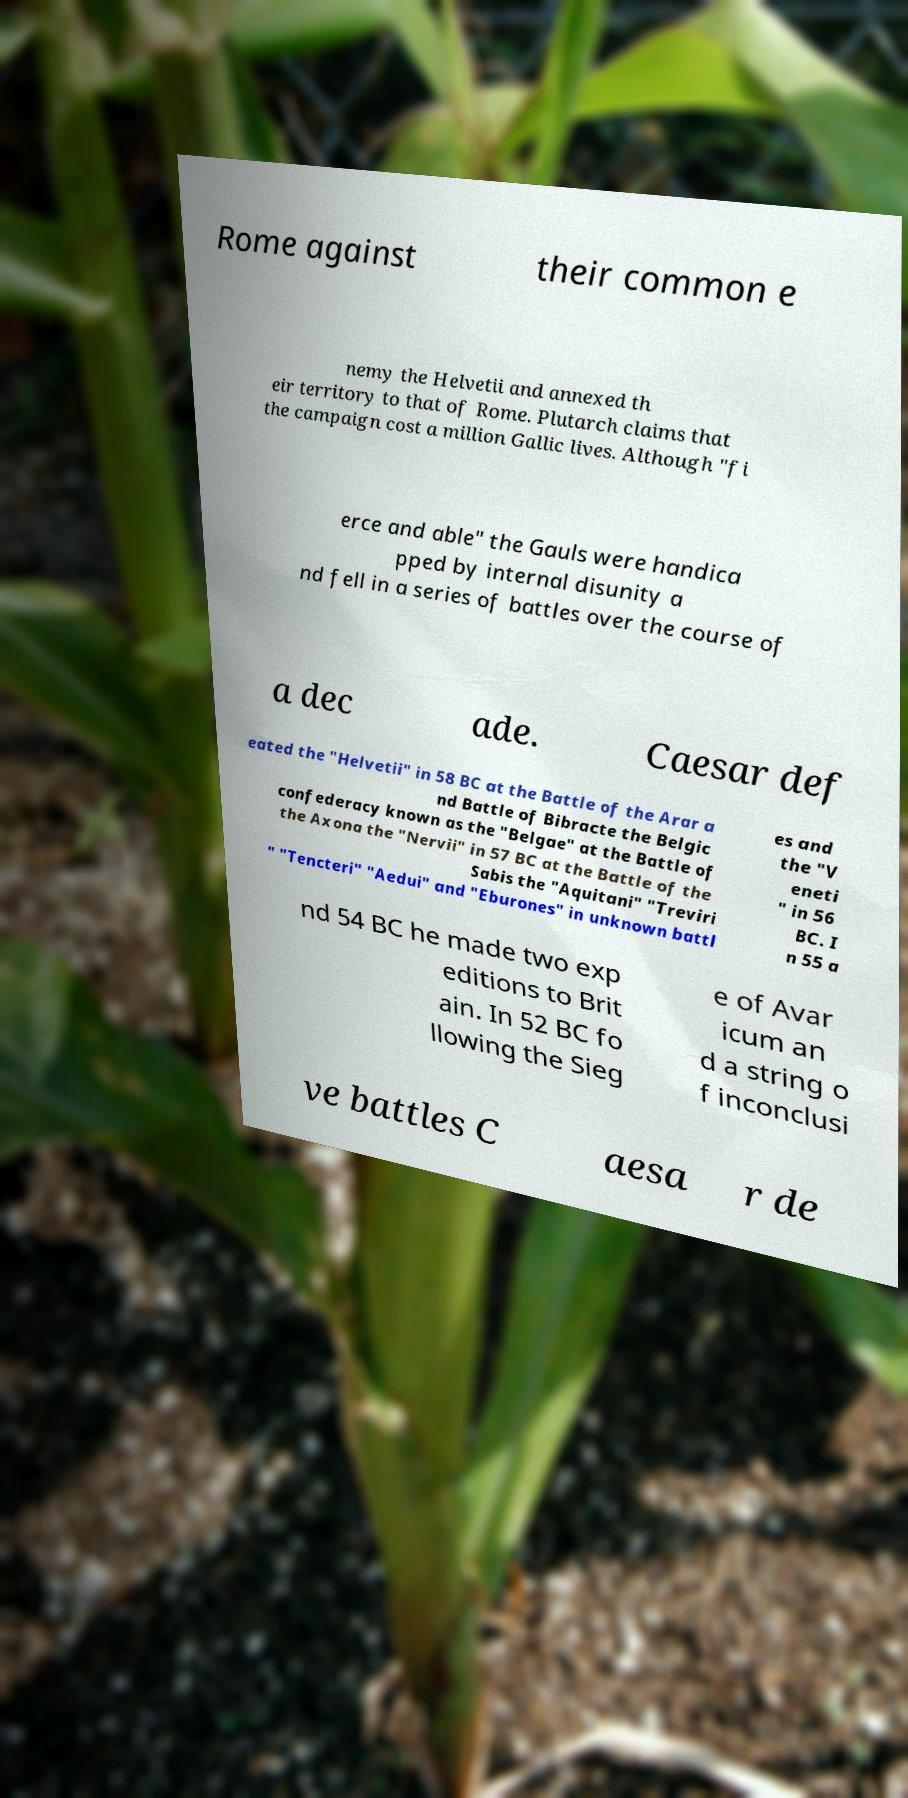Can you accurately transcribe the text from the provided image for me? Rome against their common e nemy the Helvetii and annexed th eir territory to that of Rome. Plutarch claims that the campaign cost a million Gallic lives. Although "fi erce and able" the Gauls were handica pped by internal disunity a nd fell in a series of battles over the course of a dec ade. Caesar def eated the "Helvetii" in 58 BC at the Battle of the Arar a nd Battle of Bibracte the Belgic confederacy known as the "Belgae" at the Battle of the Axona the "Nervii" in 57 BC at the Battle of the Sabis the "Aquitani" "Treviri " "Tencteri" "Aedui" and "Eburones" in unknown battl es and the "V eneti " in 56 BC. I n 55 a nd 54 BC he made two exp editions to Brit ain. In 52 BC fo llowing the Sieg e of Avar icum an d a string o f inconclusi ve battles C aesa r de 